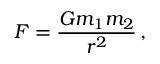<formula> <loc_0><loc_0><loc_500><loc_500>F = \frac { G m _ { 1 } m _ { 2 } } { r ^ { 2 } } \, ,</formula> 